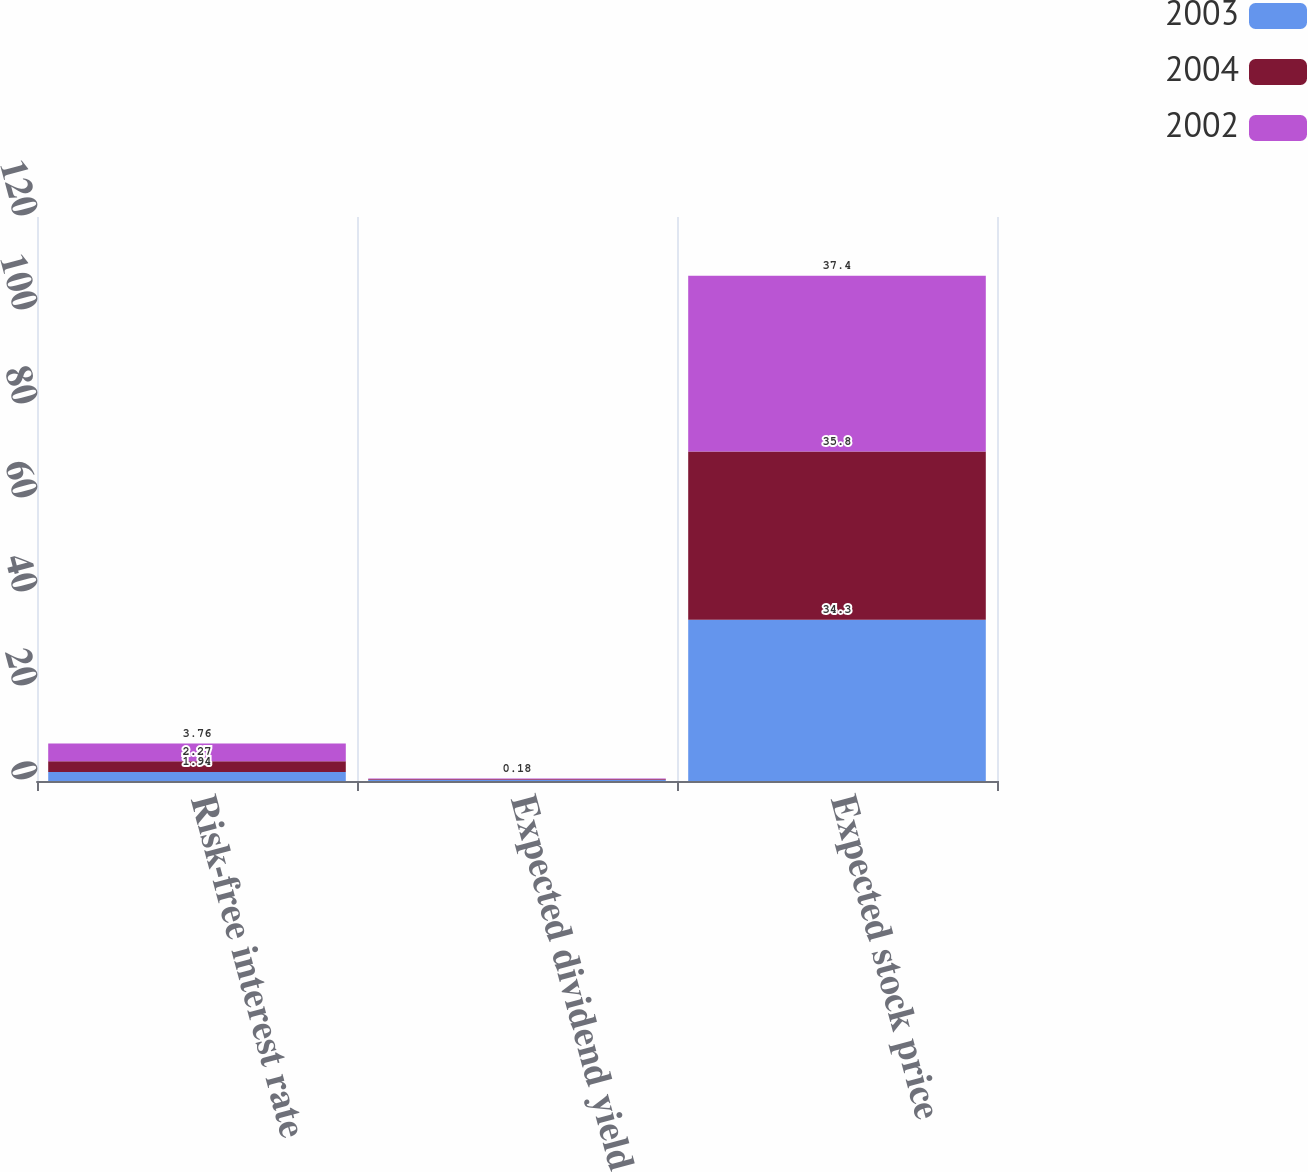Convert chart. <chart><loc_0><loc_0><loc_500><loc_500><stacked_bar_chart><ecel><fcel>Risk-free interest rate<fcel>Expected dividend yield<fcel>Expected stock price<nl><fcel>2003<fcel>1.94<fcel>0.19<fcel>34.3<nl><fcel>2004<fcel>2.27<fcel>0.18<fcel>35.8<nl><fcel>2002<fcel>3.76<fcel>0.18<fcel>37.4<nl></chart> 